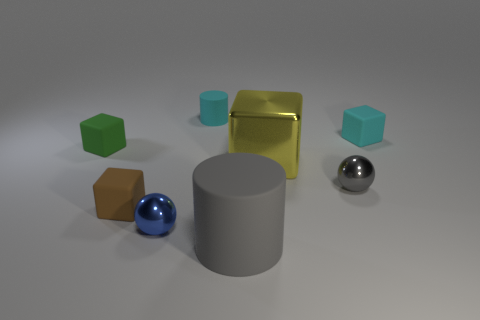Is the number of tiny brown blocks behind the tiny green matte object the same as the number of small cyan cubes?
Make the answer very short. No. What is the shape of the yellow metal thing that is the same size as the gray rubber thing?
Your response must be concise. Cube. How many other objects are there of the same shape as the small blue object?
Keep it short and to the point. 1. Does the brown matte object have the same size as the cyan rubber cube on the right side of the small blue ball?
Ensure brevity in your answer.  Yes. What number of things are matte blocks that are to the left of the tiny brown cube or cyan blocks?
Give a very brief answer. 2. What shape is the small metallic object in front of the brown thing?
Ensure brevity in your answer.  Sphere. Is the number of tiny blocks that are left of the cyan cylinder the same as the number of big yellow metallic things that are left of the small blue metallic thing?
Make the answer very short. No. There is a block that is both to the right of the tiny green rubber object and left of the large yellow thing; what color is it?
Offer a very short reply. Brown. There is a small ball that is in front of the small rubber cube that is in front of the green matte block; what is it made of?
Provide a succinct answer. Metal. Is the size of the brown rubber block the same as the gray sphere?
Provide a short and direct response. Yes. 